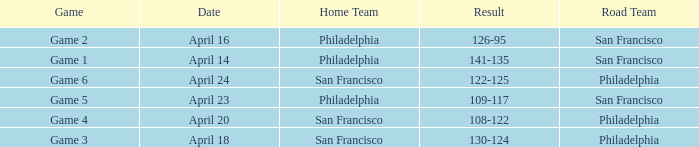Which game had Philadelphia as its home team and was played on April 23? Game 5. 